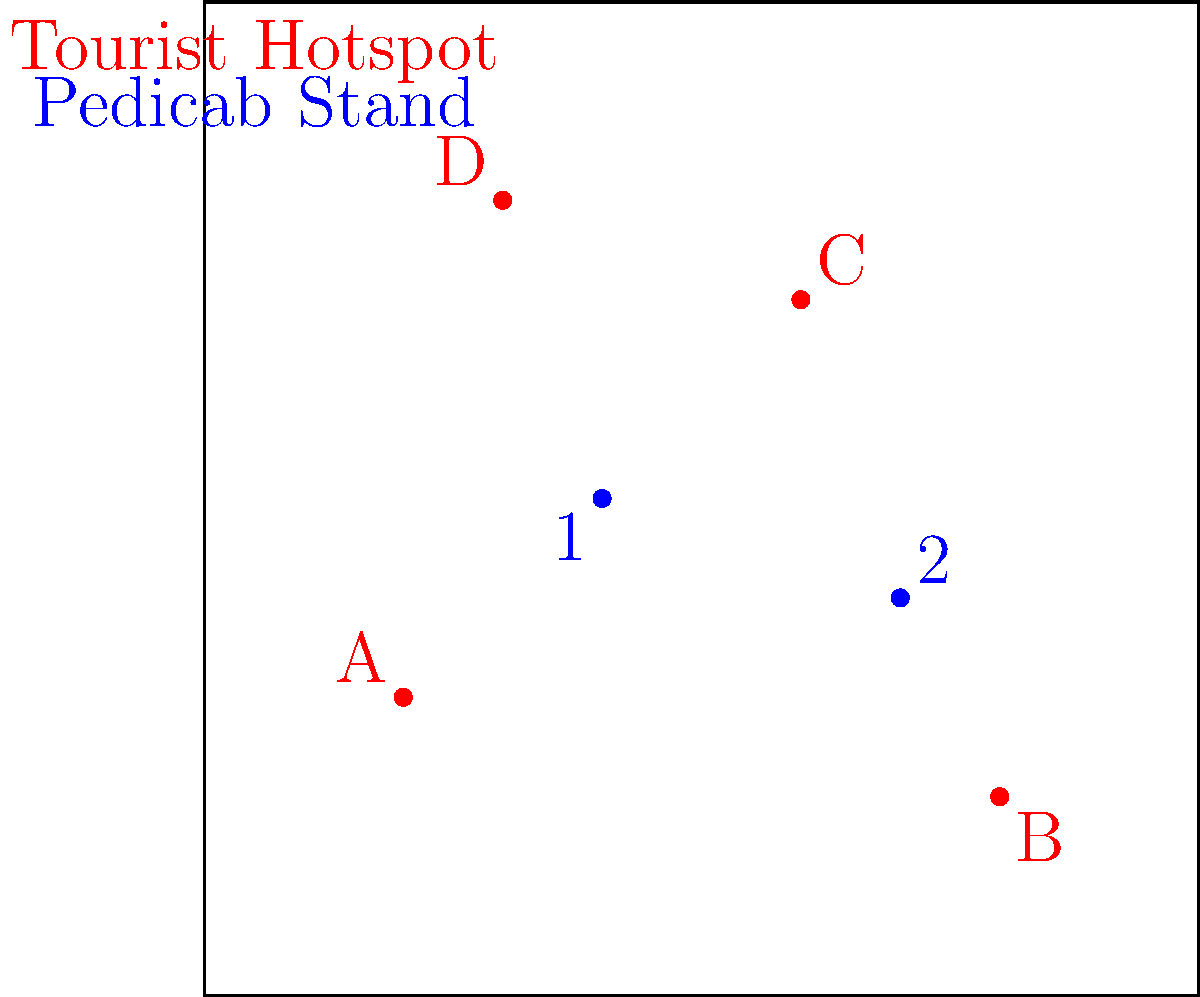Given the map of tourist hotspots (A, B, C, D) and current pedicab stands (1, 2), which tourist hotspot would benefit most from a new pedicab stand to improve overall coverage and accessibility? To determine the optimal placement of a new pedicab stand, we need to consider the following steps:

1. Assess current coverage:
   - Stand 1 is centrally located, providing decent access to hotspots A and D.
   - Stand 2 is well-positioned to serve hotspot B.

2. Identify gaps in coverage:
   - Hotspot C appears to be the farthest from both existing stands.

3. Consider distance and accessibility:
   - The new stand should minimize the maximum distance to the poorly served hotspot.
   - It should also maintain good overall coverage for all hotspots.

4. Evaluate potential locations:
   - Placing a stand near hotspot C would significantly improve its accessibility.
   - This location would also provide a good balance for overall coverage.

5. Impact on network:
   - A stand near C would create a triangular network with stands 1 and 2, maximizing area coverage.

6. Tourist flow considerations:
   - As a pedicab driver, you know that improving access to underserved areas can increase overall demand and improve service efficiency.

Given these factors, hotspot C would benefit most from a new pedicab stand, as it is currently the least accessible and its location would optimize the overall network coverage.
Answer: Hotspot C 